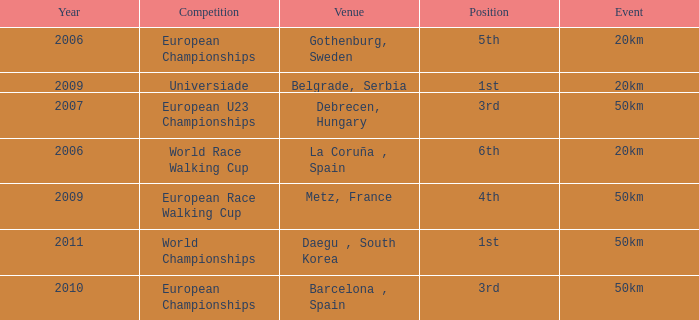What is the Position for the European U23 Championships? 3rd. 